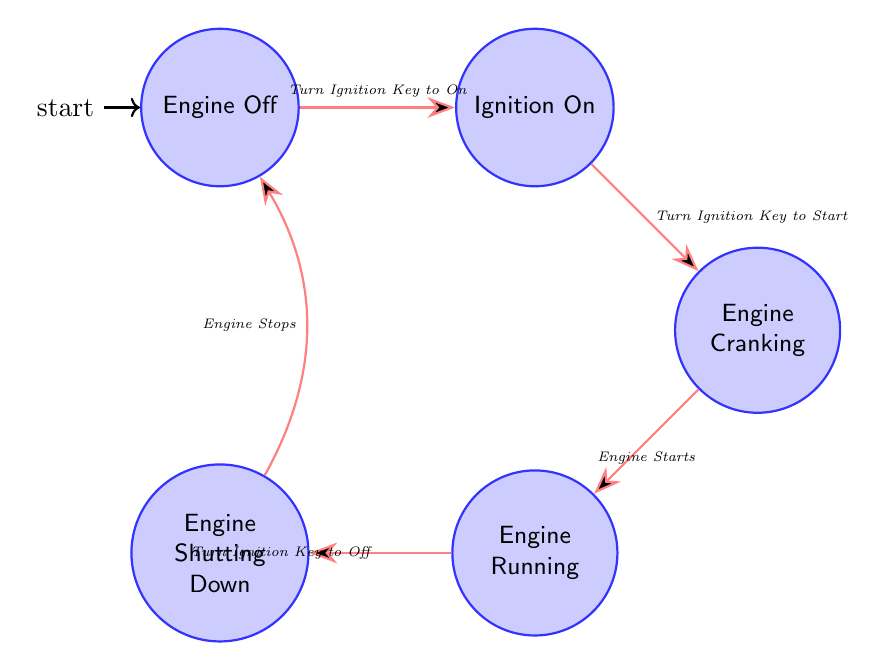What is the initial state of the system? The initial state of the system is indicated by the label "initial" next to the node for "Engine Off." This shows that when the system starts, it is in the "Engine Off" state.
Answer: Engine Off How many states are there in the diagram? The diagram lists five distinct states: Engine Off, Ignition On, Engine Cranking, Engine Running, and Engine Shutting Down. Counting these gives a total of five states.
Answer: 5 Which state occurs after "Ignition On"? Looking at the transition from "Ignition On," the next state reached is "Engine Cranking" triggered by turning the ignition key to the start position.
Answer: Engine Cranking What triggers the transition from "Engine Cranking" to "Engine Running"? The transition from "Engine Cranking" to "Engine Running" is triggered by the event "Engine Starts." This event signifies that the engine has successfully started.
Answer: Engine Starts What condition must be met to transition from "Engine Off" to "Ignition On"? The transition requires the ignition key to be "inserted and turned to the 'On' position." This condition must be satisfied for the transition to occur.
Answer: Ignition key inserted and turned to 'On' What action is associated with the transition from "Engine Running" to "Engine Shutting Down"? The action associated with transitioning to "Engine Shutting Down" is "Turn Ignition Key to Off." This action indicates that the driver is initiating the shutdown process.
Answer: Turn Ignition Key to Off After transitioning to "Engine Shutting Down," what is the next state? The next state after "Engine Shutting Down" is "Engine Off," as indicated in the diagram after the transition is triggered by the event "Engine Stops."
Answer: Engine Off Which transition has the condition related to battery charge? The transition from "Ignition On" to "Engine Cranking" has a condition regarding battery health, specifically requiring "battery has sufficient charge" to proceed with starting the engine.
Answer: battery has sufficient charge What are all the transitions from "Engine Running"? The only transition from "Engine Running" is to "Engine Shutting Down," triggered by turning the ignition key to the "Off" position. This indicates that the engine is being turned off.
Answer: Engine Shutting Down 